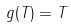<formula> <loc_0><loc_0><loc_500><loc_500>g ( T ) = T</formula> 